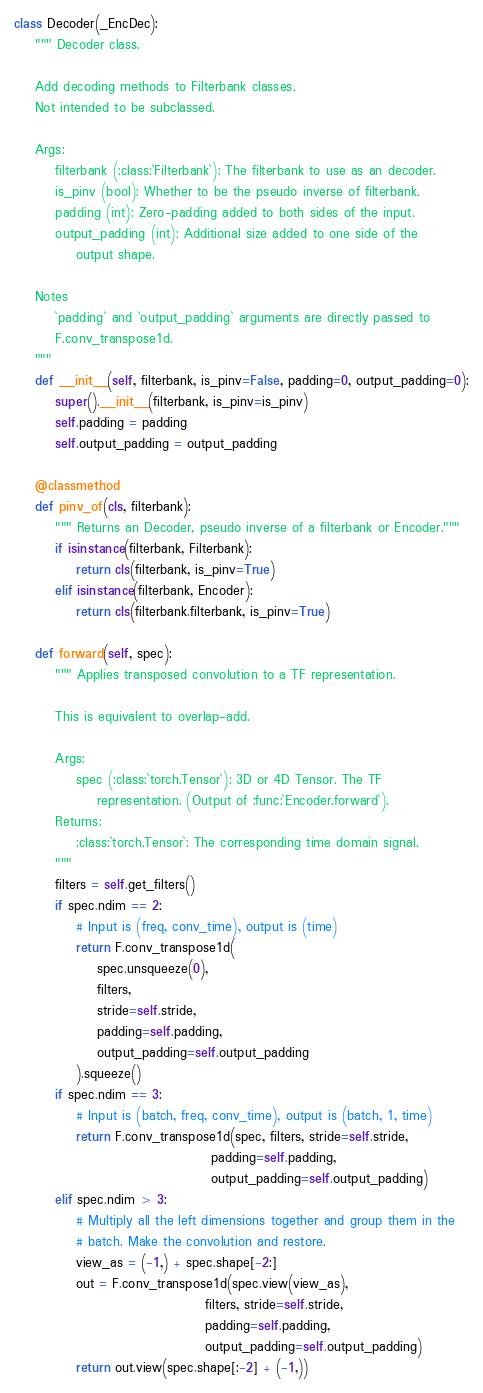<code> <loc_0><loc_0><loc_500><loc_500><_Python_>

class Decoder(_EncDec):
    """ Decoder class.
    
    Add decoding methods to Filterbank classes.
    Not intended to be subclassed.

    Args:
        filterbank (:class:`Filterbank`): The filterbank to use as an decoder.
        is_pinv (bool): Whether to be the pseudo inverse of filterbank.
        padding (int): Zero-padding added to both sides of the input.
        output_padding (int): Additional size added to one side of the
            output shape.

    Notes
        `padding` and `output_padding` arguments are directly passed to
        F.conv_transpose1d.
    """
    def __init__(self, filterbank, is_pinv=False, padding=0, output_padding=0):
        super().__init__(filterbank, is_pinv=is_pinv)
        self.padding = padding
        self.output_padding = output_padding

    @classmethod
    def pinv_of(cls, filterbank):
        """ Returns an Decoder, pseudo inverse of a filterbank or Encoder."""
        if isinstance(filterbank, Filterbank):
            return cls(filterbank, is_pinv=True)
        elif isinstance(filterbank, Encoder):
            return cls(filterbank.filterbank, is_pinv=True)

    def forward(self, spec):
        """ Applies transposed convolution to a TF representation.

        This is equivalent to overlap-add.

        Args:
            spec (:class:`torch.Tensor`): 3D or 4D Tensor. The TF
                representation. (Output of :func:`Encoder.forward`).
        Returns:
            :class:`torch.Tensor`: The corresponding time domain signal.
        """
        filters = self.get_filters()
        if spec.ndim == 2:
            # Input is (freq, conv_time), output is (time)
            return F.conv_transpose1d(
                spec.unsqueeze(0),
                filters,
                stride=self.stride,
                padding=self.padding,
                output_padding=self.output_padding
            ).squeeze()
        if spec.ndim == 3:
            # Input is (batch, freq, conv_time), output is (batch, 1, time)
            return F.conv_transpose1d(spec, filters, stride=self.stride,
                                      padding=self.padding,
                                      output_padding=self.output_padding)
        elif spec.ndim > 3:
            # Multiply all the left dimensions together and group them in the
            # batch. Make the convolution and restore.
            view_as = (-1,) + spec.shape[-2:]
            out = F.conv_transpose1d(spec.view(view_as),
                                     filters, stride=self.stride,
                                     padding=self.padding,
                                     output_padding=self.output_padding)
            return out.view(spec.shape[:-2] + (-1,))
</code> 